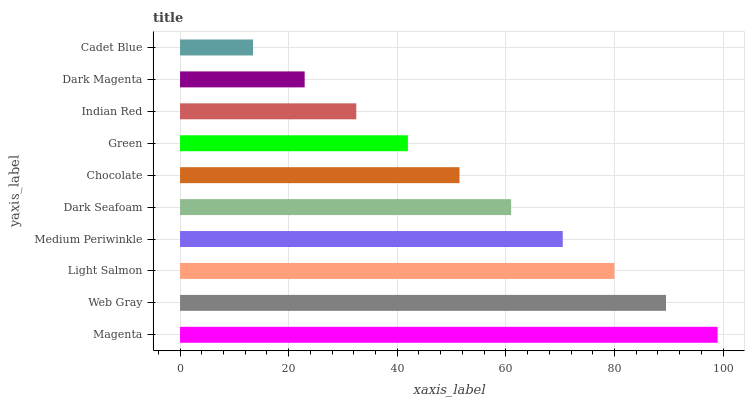Is Cadet Blue the minimum?
Answer yes or no. Yes. Is Magenta the maximum?
Answer yes or no. Yes. Is Web Gray the minimum?
Answer yes or no. No. Is Web Gray the maximum?
Answer yes or no. No. Is Magenta greater than Web Gray?
Answer yes or no. Yes. Is Web Gray less than Magenta?
Answer yes or no. Yes. Is Web Gray greater than Magenta?
Answer yes or no. No. Is Magenta less than Web Gray?
Answer yes or no. No. Is Dark Seafoam the high median?
Answer yes or no. Yes. Is Chocolate the low median?
Answer yes or no. Yes. Is Light Salmon the high median?
Answer yes or no. No. Is Web Gray the low median?
Answer yes or no. No. 